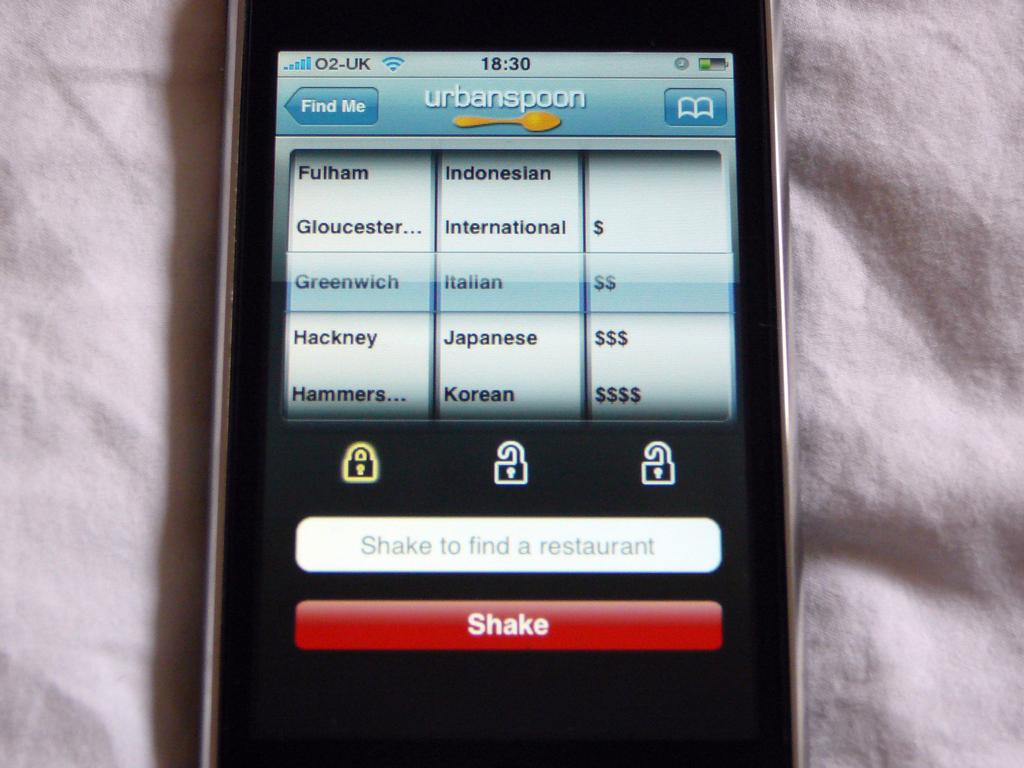<image>
Write a terse but informative summary of the picture. A phone is open to the Urbanspoon app searching for Italian food in Greenwich. 